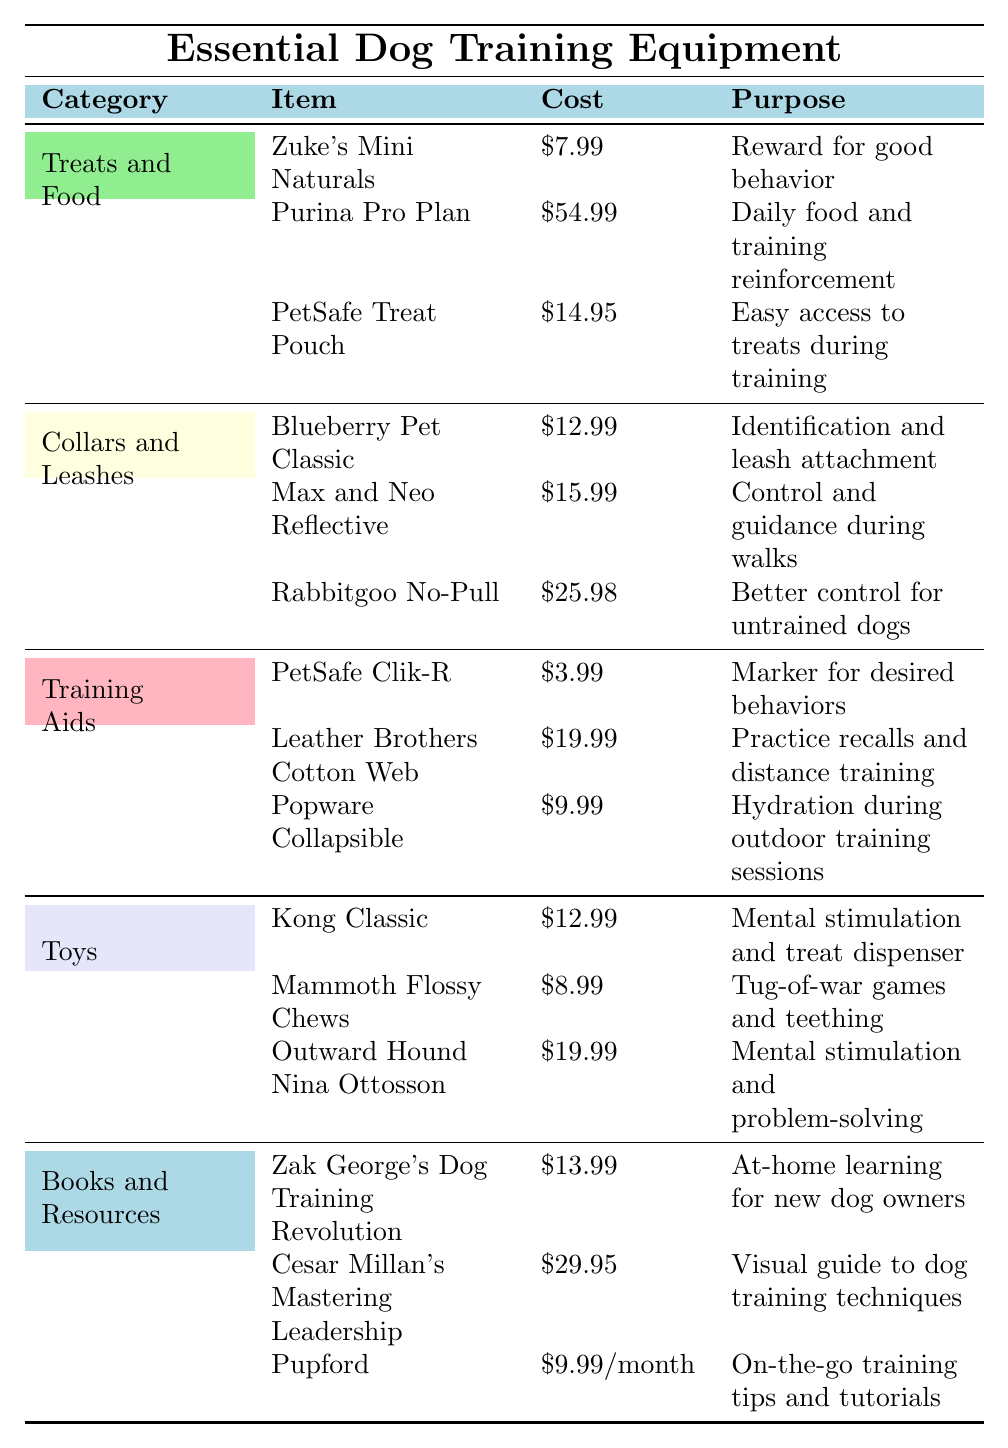What is the cost of the clicker used for training? The table shows that the cost associated with the clicker (PetSafe Clik-R) is listed under the "Training Aids" category as $3.99.
Answer: $3.99 How much do training treats cost compared to kibble? Training treats cost $7.99 while kibble costs $54.99. The difference between them is calculated as $54.99 - $7.99 = $47.00, indicating kibble is much more expensive.
Answer: $47.00 Which item is the most expensive in the "Collars and Leashes" category? In the "Collars and Leashes" category, the item with the highest cost is the Rabbitgoo No-Pull harness, which is priced at $25.98.
Answer: Rabbitgoo No-Pull Are training aids generally cheaper than treats and food? The total cost of items under "Training Aids" is $3.99 + $19.99 + $9.99 = $33.97. For "Treats and Food," it's $7.99 + $54.99 + $14.95 = $77.93. Since $33.97 is less than $77.93, training aids are indeed cheaper.
Answer: Yes What is the average cost of toys listed in the table? The costs of toys are $12.99, $8.99, and $19.99. Summing them gives $12.99 + $8.99 + $19.99 = $41.97. To find the average, we divide this total by the number of toy items, which is 3: $41.97 / 3 = $13.99.
Answer: $13.99 Is there any item in the "Books and Resources" category that costs less than $10? The items in "Books and Resources" are $13.99, $29.95, and a subscription at $9.99/month. Only the subscription is less than $10, confirming that there is an item in this category costing under $10.
Answer: Yes What is the total cost of treats, kibble, and the treat pouch? The total cost of treats (Zuke's Mini Naturals at $7.99), kibble (Purina Pro Plan at $54.99), and the treat pouch (PetSafe Treat Pouch at $14.95) sums up as $7.99 + $54.99 + $14.95 = $77.93.
Answer: $77.93 Which category has the lowest average item cost? To find the average for each category, we calculate: Treats and Food: ($7.99 + $54.99 + $14.95) / 3 = $25.31, Collars and Leashes: ($12.99 + $15.99 + $25.98) / 3 = $18.32, Training Aids: ($3.99 + $19.99 + $9.99) / 3 = $11.66, Toys: ($12.99 + $8.99 + $19.99) / 3 = $13.99, Books and Resources: ($13.99 + $29.95 + $9.99) / 3 = $17.31. The lowest average is from Training Aids at $11.66.
Answer: Training Aids What is the most affordable item in the entire table? Scanning through the table reveals that the clicker (PetSafe Clik-R) costs $3.99, which is indeed the lowest price listed.
Answer: $3.99 